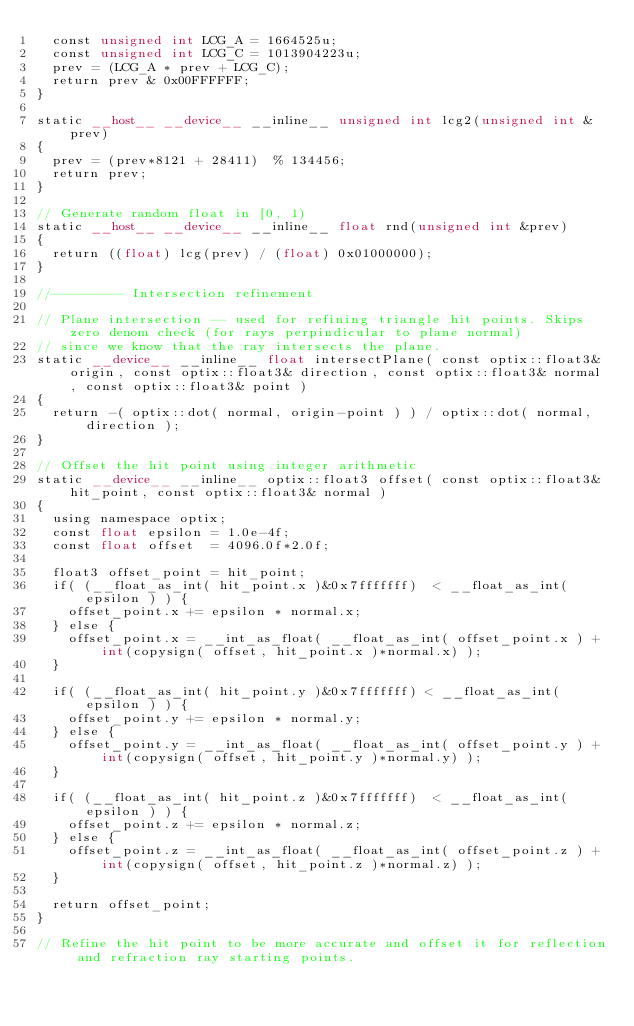<code> <loc_0><loc_0><loc_500><loc_500><_Cuda_>  const unsigned int LCG_A = 1664525u;
  const unsigned int LCG_C = 1013904223u;
  prev = (LCG_A * prev + LCG_C);
  return prev & 0x00FFFFFF;
}

static __host__ __device__ __inline__ unsigned int lcg2(unsigned int &prev)
{
  prev = (prev*8121 + 28411)  % 134456;
  return prev;
}

// Generate random float in [0, 1)
static __host__ __device__ __inline__ float rnd(unsigned int &prev)
{
  return ((float) lcg(prev) / (float) 0x01000000);
}

//--------- Intersection refinement

// Plane intersection -- used for refining triangle hit points. Skips zero denom check (for rays perpindicular to plane normal)
// since we know that the ray intersects the plane.
static __device__ __inline__ float intersectPlane( const optix::float3& origin, const optix::float3& direction, const optix::float3& normal, const optix::float3& point )
{
  return -( optix::dot( normal, origin-point ) ) / optix::dot( normal, direction );
}

// Offset the hit point using integer arithmetic
static __device__ __inline__ optix::float3 offset( const optix::float3& hit_point, const optix::float3& normal )
{
  using namespace optix;
  const float epsilon = 1.0e-4f;
  const float offset  = 4096.0f*2.0f;

  float3 offset_point = hit_point;
  if( (__float_as_int( hit_point.x )&0x7fffffff)  < __float_as_int( epsilon ) ) {
    offset_point.x += epsilon * normal.x;
  } else {
    offset_point.x = __int_as_float( __float_as_int( offset_point.x ) + int(copysign( offset, hit_point.x )*normal.x) );
  }

  if( (__float_as_int( hit_point.y )&0x7fffffff) < __float_as_int( epsilon ) ) {
    offset_point.y += epsilon * normal.y;
  } else {
    offset_point.y = __int_as_float( __float_as_int( offset_point.y ) + int(copysign( offset, hit_point.y )*normal.y) );
  }

  if( (__float_as_int( hit_point.z )&0x7fffffff)  < __float_as_int( epsilon ) ) {
    offset_point.z += epsilon * normal.z;
  } else {
    offset_point.z = __int_as_float( __float_as_int( offset_point.z ) + int(copysign( offset, hit_point.z )*normal.z) );
  }

  return offset_point;
}

// Refine the hit point to be more accurate and offset it for reflection and refraction ray starting points.</code> 